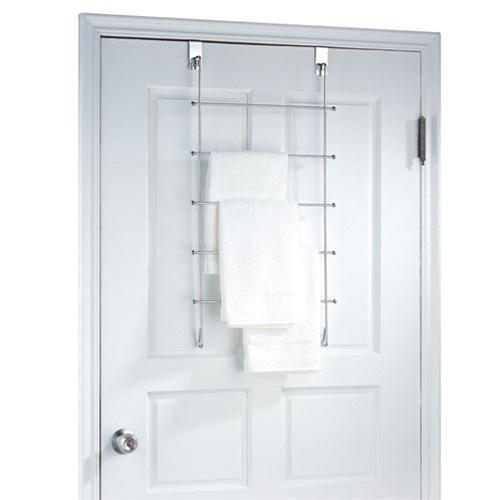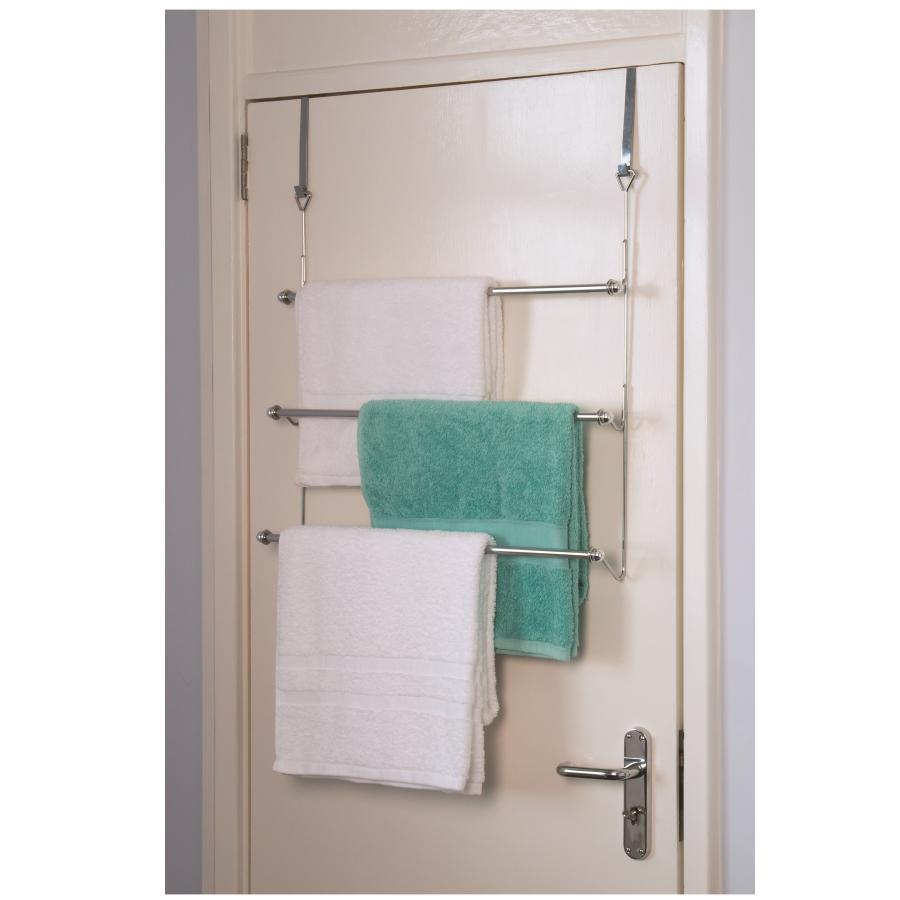The first image is the image on the left, the second image is the image on the right. Analyze the images presented: Is the assertion "The left and right image contains the same number of metal racks that can hold towels." valid? Answer yes or no. No. The first image is the image on the left, the second image is the image on the right. Given the left and right images, does the statement "Each image features an over-the-door chrome towel bar with at least 3 bars and at least one hanging towel." hold true? Answer yes or no. Yes. 